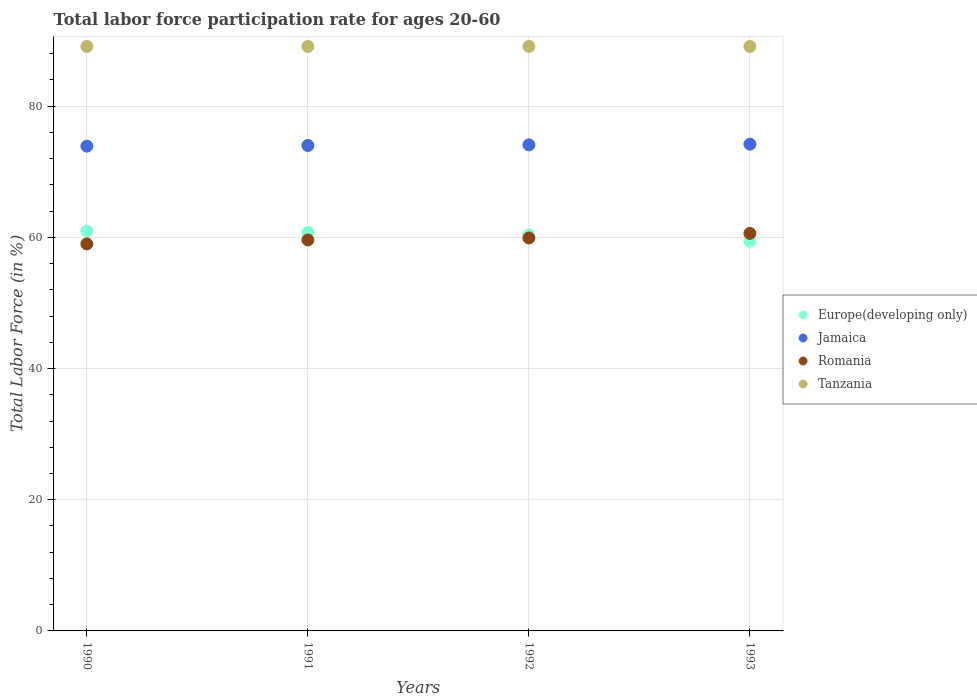How many different coloured dotlines are there?
Your answer should be compact. 4. What is the labor force participation rate in Europe(developing only) in 1990?
Provide a short and direct response. 60.96. Across all years, what is the maximum labor force participation rate in Jamaica?
Offer a very short reply. 74.2. Across all years, what is the minimum labor force participation rate in Europe(developing only)?
Offer a very short reply. 59.42. In which year was the labor force participation rate in Tanzania maximum?
Give a very brief answer. 1990. What is the total labor force participation rate in Europe(developing only) in the graph?
Provide a succinct answer. 241.53. What is the difference between the labor force participation rate in Jamaica in 1991 and that in 1992?
Ensure brevity in your answer.  -0.1. What is the difference between the labor force participation rate in Jamaica in 1993 and the labor force participation rate in Europe(developing only) in 1990?
Make the answer very short. 13.24. What is the average labor force participation rate in Tanzania per year?
Ensure brevity in your answer.  89.1. In the year 1991, what is the difference between the labor force participation rate in Jamaica and labor force participation rate in Europe(developing only)?
Offer a very short reply. 13.24. In how many years, is the labor force participation rate in Tanzania greater than 8 %?
Your answer should be very brief. 4. Is the difference between the labor force participation rate in Jamaica in 1990 and 1991 greater than the difference between the labor force participation rate in Europe(developing only) in 1990 and 1991?
Provide a short and direct response. No. What is the difference between the highest and the second highest labor force participation rate in Europe(developing only)?
Your answer should be very brief. 0.2. What is the difference between the highest and the lowest labor force participation rate in Europe(developing only)?
Provide a succinct answer. 1.54. Is the sum of the labor force participation rate in Jamaica in 1990 and 1991 greater than the maximum labor force participation rate in Romania across all years?
Give a very brief answer. Yes. Is it the case that in every year, the sum of the labor force participation rate in Tanzania and labor force participation rate in Romania  is greater than the sum of labor force participation rate in Jamaica and labor force participation rate in Europe(developing only)?
Your response must be concise. Yes. Does the labor force participation rate in Romania monotonically increase over the years?
Offer a very short reply. Yes. Is the labor force participation rate in Europe(developing only) strictly greater than the labor force participation rate in Romania over the years?
Make the answer very short. No. Are the values on the major ticks of Y-axis written in scientific E-notation?
Your answer should be compact. No. Does the graph contain any zero values?
Your response must be concise. No. Does the graph contain grids?
Make the answer very short. Yes. How many legend labels are there?
Give a very brief answer. 4. What is the title of the graph?
Offer a very short reply. Total labor force participation rate for ages 20-60. Does "Ghana" appear as one of the legend labels in the graph?
Your response must be concise. No. What is the label or title of the X-axis?
Keep it short and to the point. Years. What is the label or title of the Y-axis?
Provide a succinct answer. Total Labor Force (in %). What is the Total Labor Force (in %) in Europe(developing only) in 1990?
Ensure brevity in your answer.  60.96. What is the Total Labor Force (in %) of Jamaica in 1990?
Give a very brief answer. 73.9. What is the Total Labor Force (in %) in Tanzania in 1990?
Your answer should be compact. 89.1. What is the Total Labor Force (in %) in Europe(developing only) in 1991?
Provide a short and direct response. 60.76. What is the Total Labor Force (in %) in Romania in 1991?
Your answer should be very brief. 59.6. What is the Total Labor Force (in %) of Tanzania in 1991?
Give a very brief answer. 89.1. What is the Total Labor Force (in %) of Europe(developing only) in 1992?
Offer a terse response. 60.39. What is the Total Labor Force (in %) in Jamaica in 1992?
Ensure brevity in your answer.  74.1. What is the Total Labor Force (in %) of Romania in 1992?
Offer a terse response. 59.9. What is the Total Labor Force (in %) of Tanzania in 1992?
Your answer should be compact. 89.1. What is the Total Labor Force (in %) of Europe(developing only) in 1993?
Ensure brevity in your answer.  59.42. What is the Total Labor Force (in %) of Jamaica in 1993?
Your response must be concise. 74.2. What is the Total Labor Force (in %) of Romania in 1993?
Keep it short and to the point. 60.6. What is the Total Labor Force (in %) of Tanzania in 1993?
Your answer should be compact. 89.1. Across all years, what is the maximum Total Labor Force (in %) in Europe(developing only)?
Your response must be concise. 60.96. Across all years, what is the maximum Total Labor Force (in %) of Jamaica?
Your answer should be compact. 74.2. Across all years, what is the maximum Total Labor Force (in %) of Romania?
Offer a very short reply. 60.6. Across all years, what is the maximum Total Labor Force (in %) in Tanzania?
Provide a succinct answer. 89.1. Across all years, what is the minimum Total Labor Force (in %) of Europe(developing only)?
Give a very brief answer. 59.42. Across all years, what is the minimum Total Labor Force (in %) of Jamaica?
Ensure brevity in your answer.  73.9. Across all years, what is the minimum Total Labor Force (in %) of Romania?
Give a very brief answer. 59. Across all years, what is the minimum Total Labor Force (in %) in Tanzania?
Offer a terse response. 89.1. What is the total Total Labor Force (in %) of Europe(developing only) in the graph?
Ensure brevity in your answer.  241.53. What is the total Total Labor Force (in %) of Jamaica in the graph?
Your answer should be very brief. 296.2. What is the total Total Labor Force (in %) in Romania in the graph?
Your response must be concise. 239.1. What is the total Total Labor Force (in %) in Tanzania in the graph?
Ensure brevity in your answer.  356.4. What is the difference between the Total Labor Force (in %) in Europe(developing only) in 1990 and that in 1991?
Ensure brevity in your answer.  0.2. What is the difference between the Total Labor Force (in %) in Tanzania in 1990 and that in 1991?
Your answer should be very brief. 0. What is the difference between the Total Labor Force (in %) in Europe(developing only) in 1990 and that in 1992?
Ensure brevity in your answer.  0.57. What is the difference between the Total Labor Force (in %) of Jamaica in 1990 and that in 1992?
Give a very brief answer. -0.2. What is the difference between the Total Labor Force (in %) in Romania in 1990 and that in 1992?
Your answer should be compact. -0.9. What is the difference between the Total Labor Force (in %) of Europe(developing only) in 1990 and that in 1993?
Provide a short and direct response. 1.54. What is the difference between the Total Labor Force (in %) in Jamaica in 1990 and that in 1993?
Give a very brief answer. -0.3. What is the difference between the Total Labor Force (in %) of Tanzania in 1990 and that in 1993?
Provide a short and direct response. 0. What is the difference between the Total Labor Force (in %) in Europe(developing only) in 1991 and that in 1992?
Ensure brevity in your answer.  0.37. What is the difference between the Total Labor Force (in %) of Jamaica in 1991 and that in 1992?
Give a very brief answer. -0.1. What is the difference between the Total Labor Force (in %) in Romania in 1991 and that in 1992?
Keep it short and to the point. -0.3. What is the difference between the Total Labor Force (in %) in Europe(developing only) in 1991 and that in 1993?
Your answer should be compact. 1.35. What is the difference between the Total Labor Force (in %) in Romania in 1991 and that in 1993?
Your answer should be very brief. -1. What is the difference between the Total Labor Force (in %) of Europe(developing only) in 1992 and that in 1993?
Your response must be concise. 0.98. What is the difference between the Total Labor Force (in %) of Tanzania in 1992 and that in 1993?
Give a very brief answer. 0. What is the difference between the Total Labor Force (in %) in Europe(developing only) in 1990 and the Total Labor Force (in %) in Jamaica in 1991?
Your answer should be very brief. -13.04. What is the difference between the Total Labor Force (in %) in Europe(developing only) in 1990 and the Total Labor Force (in %) in Romania in 1991?
Provide a short and direct response. 1.36. What is the difference between the Total Labor Force (in %) of Europe(developing only) in 1990 and the Total Labor Force (in %) of Tanzania in 1991?
Keep it short and to the point. -28.14. What is the difference between the Total Labor Force (in %) in Jamaica in 1990 and the Total Labor Force (in %) in Romania in 1991?
Give a very brief answer. 14.3. What is the difference between the Total Labor Force (in %) of Jamaica in 1990 and the Total Labor Force (in %) of Tanzania in 1991?
Keep it short and to the point. -15.2. What is the difference between the Total Labor Force (in %) of Romania in 1990 and the Total Labor Force (in %) of Tanzania in 1991?
Give a very brief answer. -30.1. What is the difference between the Total Labor Force (in %) of Europe(developing only) in 1990 and the Total Labor Force (in %) of Jamaica in 1992?
Make the answer very short. -13.14. What is the difference between the Total Labor Force (in %) in Europe(developing only) in 1990 and the Total Labor Force (in %) in Romania in 1992?
Your response must be concise. 1.06. What is the difference between the Total Labor Force (in %) of Europe(developing only) in 1990 and the Total Labor Force (in %) of Tanzania in 1992?
Make the answer very short. -28.14. What is the difference between the Total Labor Force (in %) of Jamaica in 1990 and the Total Labor Force (in %) of Romania in 1992?
Give a very brief answer. 14. What is the difference between the Total Labor Force (in %) of Jamaica in 1990 and the Total Labor Force (in %) of Tanzania in 1992?
Your response must be concise. -15.2. What is the difference between the Total Labor Force (in %) in Romania in 1990 and the Total Labor Force (in %) in Tanzania in 1992?
Provide a short and direct response. -30.1. What is the difference between the Total Labor Force (in %) of Europe(developing only) in 1990 and the Total Labor Force (in %) of Jamaica in 1993?
Keep it short and to the point. -13.24. What is the difference between the Total Labor Force (in %) of Europe(developing only) in 1990 and the Total Labor Force (in %) of Romania in 1993?
Provide a short and direct response. 0.36. What is the difference between the Total Labor Force (in %) of Europe(developing only) in 1990 and the Total Labor Force (in %) of Tanzania in 1993?
Make the answer very short. -28.14. What is the difference between the Total Labor Force (in %) in Jamaica in 1990 and the Total Labor Force (in %) in Romania in 1993?
Ensure brevity in your answer.  13.3. What is the difference between the Total Labor Force (in %) in Jamaica in 1990 and the Total Labor Force (in %) in Tanzania in 1993?
Give a very brief answer. -15.2. What is the difference between the Total Labor Force (in %) in Romania in 1990 and the Total Labor Force (in %) in Tanzania in 1993?
Keep it short and to the point. -30.1. What is the difference between the Total Labor Force (in %) in Europe(developing only) in 1991 and the Total Labor Force (in %) in Jamaica in 1992?
Ensure brevity in your answer.  -13.34. What is the difference between the Total Labor Force (in %) in Europe(developing only) in 1991 and the Total Labor Force (in %) in Romania in 1992?
Ensure brevity in your answer.  0.86. What is the difference between the Total Labor Force (in %) in Europe(developing only) in 1991 and the Total Labor Force (in %) in Tanzania in 1992?
Your answer should be very brief. -28.34. What is the difference between the Total Labor Force (in %) in Jamaica in 1991 and the Total Labor Force (in %) in Romania in 1992?
Your answer should be compact. 14.1. What is the difference between the Total Labor Force (in %) in Jamaica in 1991 and the Total Labor Force (in %) in Tanzania in 1992?
Your response must be concise. -15.1. What is the difference between the Total Labor Force (in %) of Romania in 1991 and the Total Labor Force (in %) of Tanzania in 1992?
Your answer should be compact. -29.5. What is the difference between the Total Labor Force (in %) of Europe(developing only) in 1991 and the Total Labor Force (in %) of Jamaica in 1993?
Your answer should be very brief. -13.44. What is the difference between the Total Labor Force (in %) of Europe(developing only) in 1991 and the Total Labor Force (in %) of Romania in 1993?
Your answer should be compact. 0.16. What is the difference between the Total Labor Force (in %) in Europe(developing only) in 1991 and the Total Labor Force (in %) in Tanzania in 1993?
Offer a very short reply. -28.34. What is the difference between the Total Labor Force (in %) in Jamaica in 1991 and the Total Labor Force (in %) in Romania in 1993?
Provide a short and direct response. 13.4. What is the difference between the Total Labor Force (in %) in Jamaica in 1991 and the Total Labor Force (in %) in Tanzania in 1993?
Your answer should be very brief. -15.1. What is the difference between the Total Labor Force (in %) of Romania in 1991 and the Total Labor Force (in %) of Tanzania in 1993?
Offer a very short reply. -29.5. What is the difference between the Total Labor Force (in %) of Europe(developing only) in 1992 and the Total Labor Force (in %) of Jamaica in 1993?
Ensure brevity in your answer.  -13.81. What is the difference between the Total Labor Force (in %) of Europe(developing only) in 1992 and the Total Labor Force (in %) of Romania in 1993?
Your answer should be very brief. -0.21. What is the difference between the Total Labor Force (in %) of Europe(developing only) in 1992 and the Total Labor Force (in %) of Tanzania in 1993?
Your answer should be compact. -28.71. What is the difference between the Total Labor Force (in %) of Jamaica in 1992 and the Total Labor Force (in %) of Romania in 1993?
Offer a very short reply. 13.5. What is the difference between the Total Labor Force (in %) in Romania in 1992 and the Total Labor Force (in %) in Tanzania in 1993?
Your answer should be very brief. -29.2. What is the average Total Labor Force (in %) of Europe(developing only) per year?
Offer a very short reply. 60.38. What is the average Total Labor Force (in %) in Jamaica per year?
Your response must be concise. 74.05. What is the average Total Labor Force (in %) of Romania per year?
Provide a short and direct response. 59.77. What is the average Total Labor Force (in %) of Tanzania per year?
Offer a very short reply. 89.1. In the year 1990, what is the difference between the Total Labor Force (in %) of Europe(developing only) and Total Labor Force (in %) of Jamaica?
Your response must be concise. -12.94. In the year 1990, what is the difference between the Total Labor Force (in %) in Europe(developing only) and Total Labor Force (in %) in Romania?
Your answer should be very brief. 1.96. In the year 1990, what is the difference between the Total Labor Force (in %) of Europe(developing only) and Total Labor Force (in %) of Tanzania?
Offer a very short reply. -28.14. In the year 1990, what is the difference between the Total Labor Force (in %) of Jamaica and Total Labor Force (in %) of Romania?
Ensure brevity in your answer.  14.9. In the year 1990, what is the difference between the Total Labor Force (in %) in Jamaica and Total Labor Force (in %) in Tanzania?
Offer a terse response. -15.2. In the year 1990, what is the difference between the Total Labor Force (in %) in Romania and Total Labor Force (in %) in Tanzania?
Your answer should be compact. -30.1. In the year 1991, what is the difference between the Total Labor Force (in %) of Europe(developing only) and Total Labor Force (in %) of Jamaica?
Your answer should be very brief. -13.24. In the year 1991, what is the difference between the Total Labor Force (in %) of Europe(developing only) and Total Labor Force (in %) of Romania?
Offer a very short reply. 1.16. In the year 1991, what is the difference between the Total Labor Force (in %) in Europe(developing only) and Total Labor Force (in %) in Tanzania?
Your answer should be compact. -28.34. In the year 1991, what is the difference between the Total Labor Force (in %) in Jamaica and Total Labor Force (in %) in Tanzania?
Keep it short and to the point. -15.1. In the year 1991, what is the difference between the Total Labor Force (in %) in Romania and Total Labor Force (in %) in Tanzania?
Your answer should be very brief. -29.5. In the year 1992, what is the difference between the Total Labor Force (in %) in Europe(developing only) and Total Labor Force (in %) in Jamaica?
Offer a terse response. -13.71. In the year 1992, what is the difference between the Total Labor Force (in %) in Europe(developing only) and Total Labor Force (in %) in Romania?
Your response must be concise. 0.49. In the year 1992, what is the difference between the Total Labor Force (in %) of Europe(developing only) and Total Labor Force (in %) of Tanzania?
Your response must be concise. -28.71. In the year 1992, what is the difference between the Total Labor Force (in %) of Romania and Total Labor Force (in %) of Tanzania?
Provide a short and direct response. -29.2. In the year 1993, what is the difference between the Total Labor Force (in %) in Europe(developing only) and Total Labor Force (in %) in Jamaica?
Your answer should be compact. -14.78. In the year 1993, what is the difference between the Total Labor Force (in %) in Europe(developing only) and Total Labor Force (in %) in Romania?
Offer a terse response. -1.18. In the year 1993, what is the difference between the Total Labor Force (in %) of Europe(developing only) and Total Labor Force (in %) of Tanzania?
Provide a short and direct response. -29.68. In the year 1993, what is the difference between the Total Labor Force (in %) of Jamaica and Total Labor Force (in %) of Tanzania?
Give a very brief answer. -14.9. In the year 1993, what is the difference between the Total Labor Force (in %) in Romania and Total Labor Force (in %) in Tanzania?
Offer a very short reply. -28.5. What is the ratio of the Total Labor Force (in %) of Europe(developing only) in 1990 to that in 1991?
Provide a short and direct response. 1. What is the ratio of the Total Labor Force (in %) in Romania in 1990 to that in 1991?
Your answer should be compact. 0.99. What is the ratio of the Total Labor Force (in %) of Europe(developing only) in 1990 to that in 1992?
Provide a succinct answer. 1.01. What is the ratio of the Total Labor Force (in %) in Romania in 1990 to that in 1993?
Provide a succinct answer. 0.97. What is the ratio of the Total Labor Force (in %) of Europe(developing only) in 1991 to that in 1993?
Your answer should be compact. 1.02. What is the ratio of the Total Labor Force (in %) of Romania in 1991 to that in 1993?
Provide a short and direct response. 0.98. What is the ratio of the Total Labor Force (in %) in Tanzania in 1991 to that in 1993?
Your response must be concise. 1. What is the ratio of the Total Labor Force (in %) of Europe(developing only) in 1992 to that in 1993?
Offer a terse response. 1.02. What is the ratio of the Total Labor Force (in %) in Jamaica in 1992 to that in 1993?
Ensure brevity in your answer.  1. What is the ratio of the Total Labor Force (in %) in Romania in 1992 to that in 1993?
Provide a succinct answer. 0.99. What is the difference between the highest and the second highest Total Labor Force (in %) of Europe(developing only)?
Keep it short and to the point. 0.2. What is the difference between the highest and the lowest Total Labor Force (in %) in Europe(developing only)?
Offer a terse response. 1.54. What is the difference between the highest and the lowest Total Labor Force (in %) of Jamaica?
Offer a terse response. 0.3. What is the difference between the highest and the lowest Total Labor Force (in %) of Romania?
Your response must be concise. 1.6. 